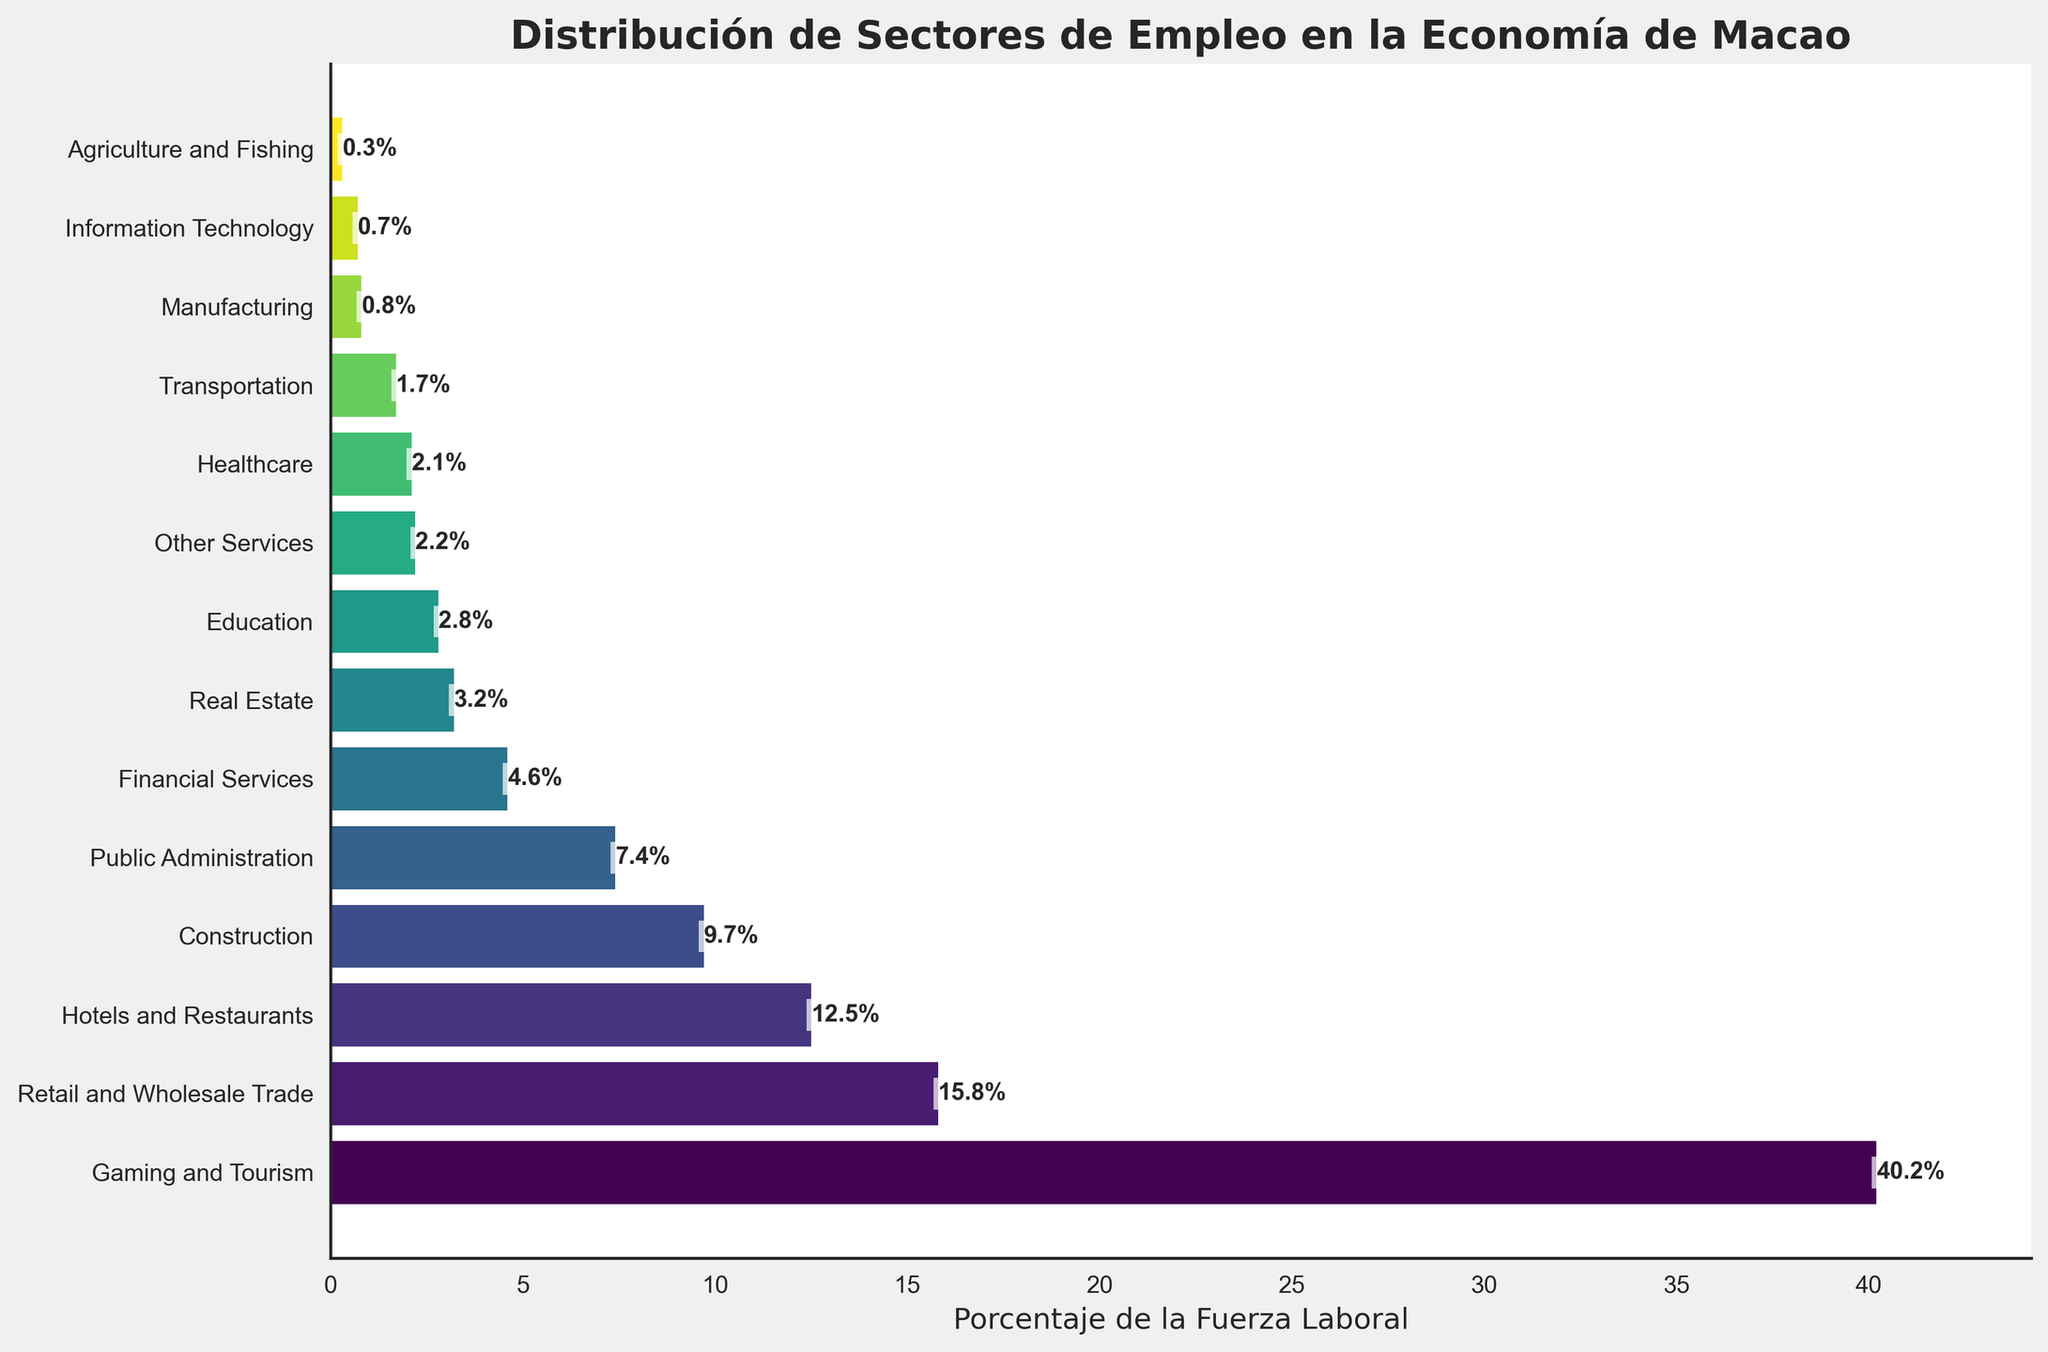What sector employs the highest percentage of the workforce? The highest percentage is indicated by the longest bar in the bar chart. "Gaming and Tourism" sector has the longest bar.
Answer: Gaming and Tourism What is the combined percentage of workforce in the Hotels and Restaurants and Healthcare sectors? Locate the bars for 'Hotels and Restaurants' and 'Healthcare' and sum their percentages (12.5% + 2.1%).
Answer: 14.6% Which sectors employ less than 5% of the workforce? Identify the sectors whose bars are shorter than the bar representing 5% on the x-axis. These include Financial Services, Real Estate, Education, Healthcare, Transportation, Manufacturing, Information Technology, and Agriculture and Fishing.
Answer: Financial Services, Real Estate, Education, Healthcare, Transportation, Manufacturing, Information Technology, Agriculture and Fishing How much more percentage of the workforce does the Gaming and Tourism sector employ compared to the Construction sector? Identify the percentages for 'Gaming and Tourism' (40.2%) and 'Construction' (9.7%) and compute the difference (40.2% - 9.7%).
Answer: 30.5% Which sector has the smallest percentage of workforce? The smallest bar corresponds to the 'Agriculture and Fishing' sector.
Answer: Agriculture and Fishing Is there a sector related to technology, and what percentage of the workforce does it employ? Locate the sectors 'Information Technology' and 'Manufacturing' (related to tech). 'Information Technology' employs 0.7%.
Answer: Information Technology, 0.7% How many sectors employ more than 10% of the workforce? Count the bars higher than 10% on the x-axis. These include Gaming and Tourism, Retail and Wholesale Trade, and Hotels and Restaurants.
Answer: 3 Is the employment in Real Estate higher or lower than in Public Administration? Compare the lengths of bars corresponding to 'Real Estate' (3.2%) and 'Public Administration' (7.4%).
Answer: Lower How does the percentage of workforce in Retail and Wholesale Trade compare to combined sectors of Financial Services and Real Estate? Sum the percentage of 'Financial Services' (4.6%) and 'Real Estate' (3.2%) and compare it to 'Retail and Wholesale Trade' (15.8%). Sum is 4.6% + 3.2% = 7.8%, which is less than 15.8%.
Answer: Higher 